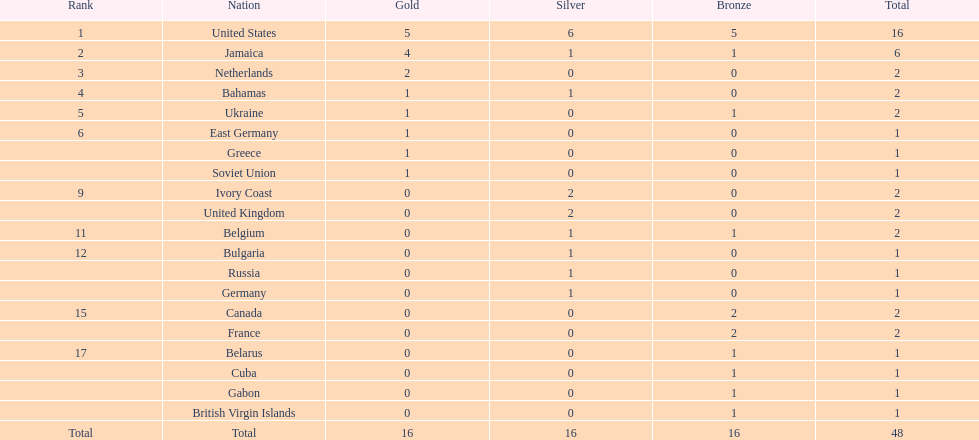How many countries were awarded one medal? 10. 